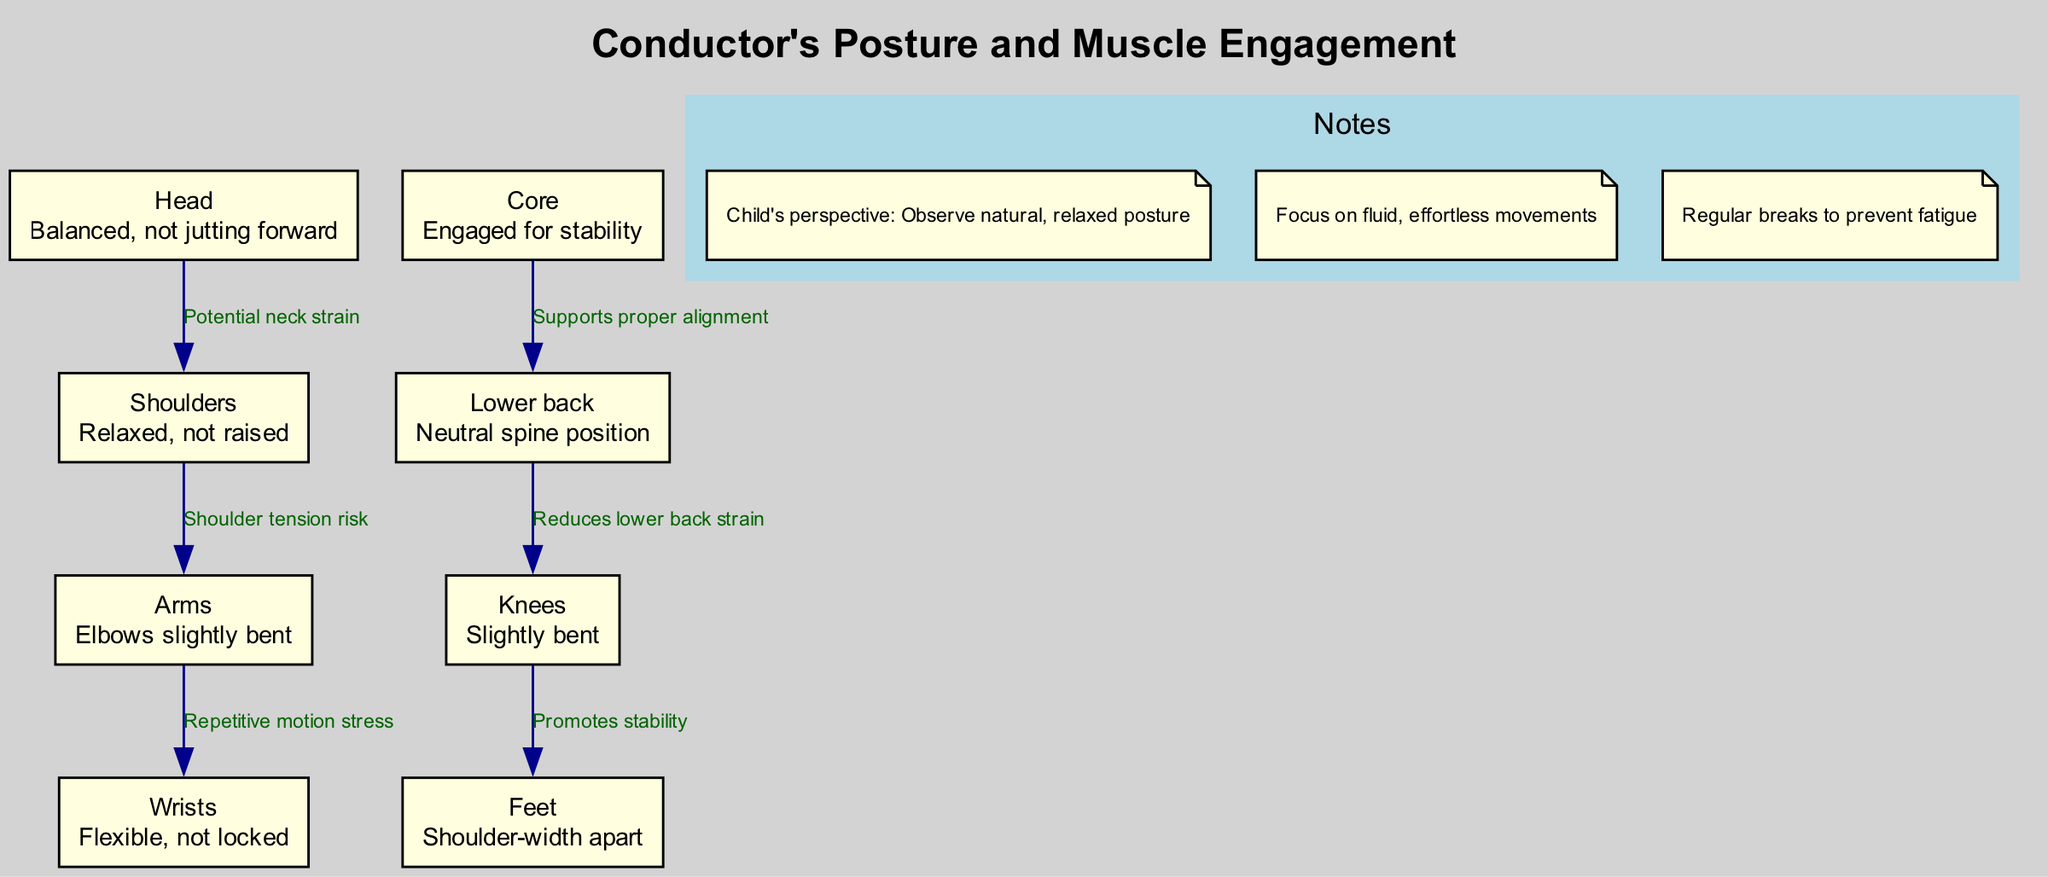What is the description of the "Core" node? The "Core" node has the description "Engaged for stability." This can be found by looking at the node labeled "Core" in the diagram and reading its accompanying description.
Answer: Engaged for stability How many nodes are present in the diagram? The diagram contains a total of 8 nodes. This was determined by counting each individual node listed under the "nodes" section in the provided data.
Answer: 8 What potential risk is associated with the "Shoulders" node? The "Shoulders" node is linked to the label "Shoulder tension risk," indicating potential risk associated with tension in the shoulders. This information is found on the edge connecting the "Shoulders" nodeto other nodes.
Answer: Shoulder tension risk What is the relationship between the "Knees" and "Feet" nodes? The "Knees" node promotes stability for the "Feet." This relationship is indicated by the edge connecting these two nodes, emphasizing how the positioning of the knees affects foot stability.
Answer: Promotes stability Which node is linked to "Repetitive motion stress"? The "Arms" node is linked to "Repetitive motion stress." This is evident from examining the edge that connects the "Arms" node to the "Wrists" node, where the relationship is labeled as "Repetitive motion stress."
Answer: Arms Explain how the "Core" influences the "Lower back" in terms of posture. The "Core" is described as "Engaged for stability," while the "Lower back" is described with "Neutral spine position." The edge between these two nodes indicates that engaging the core supports proper alignment, which is crucial for maintaining a neutral spine in the lower back. Thus, having a stable core reduces strain on the lower back.
Answer: Supports proper alignment What are the two areas that the diagram suggests can be strained? The diagram suggests that the potential strain areas are the "Neck" and "Lower back." The edges specify the potential neck strain linked to the "Head" and lower back strain associated with "Knees."
Answer: Neck and Lower back How does the posture of the "Wrists" contribute to the conductor's performance? The "Wrists" node states that they should be "Flexible, not locked," indicating that flexibility in the wrists is important to prevent strain during conducting. This is crucial for fluid and effective arm movements, which are essential in a conductor's performance.
Answer: Flexible, not locked 